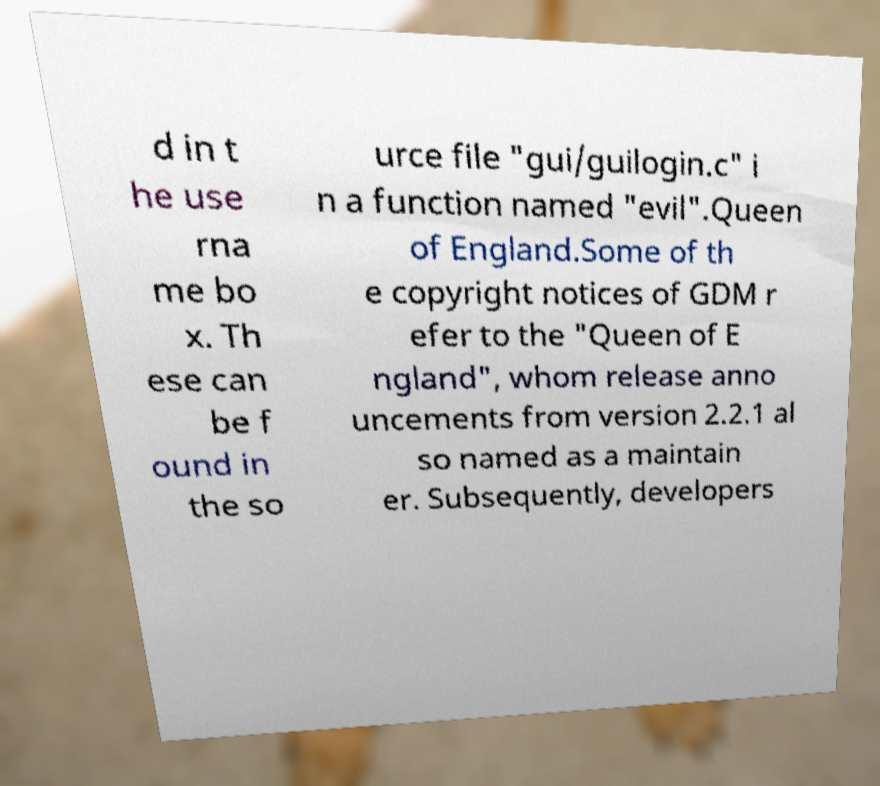Please identify and transcribe the text found in this image. d in t he use rna me bo x. Th ese can be f ound in the so urce file "gui/guilogin.c" i n a function named "evil".Queen of England.Some of th e copyright notices of GDM r efer to the "Queen of E ngland", whom release anno uncements from version 2.2.1 al so named as a maintain er. Subsequently, developers 